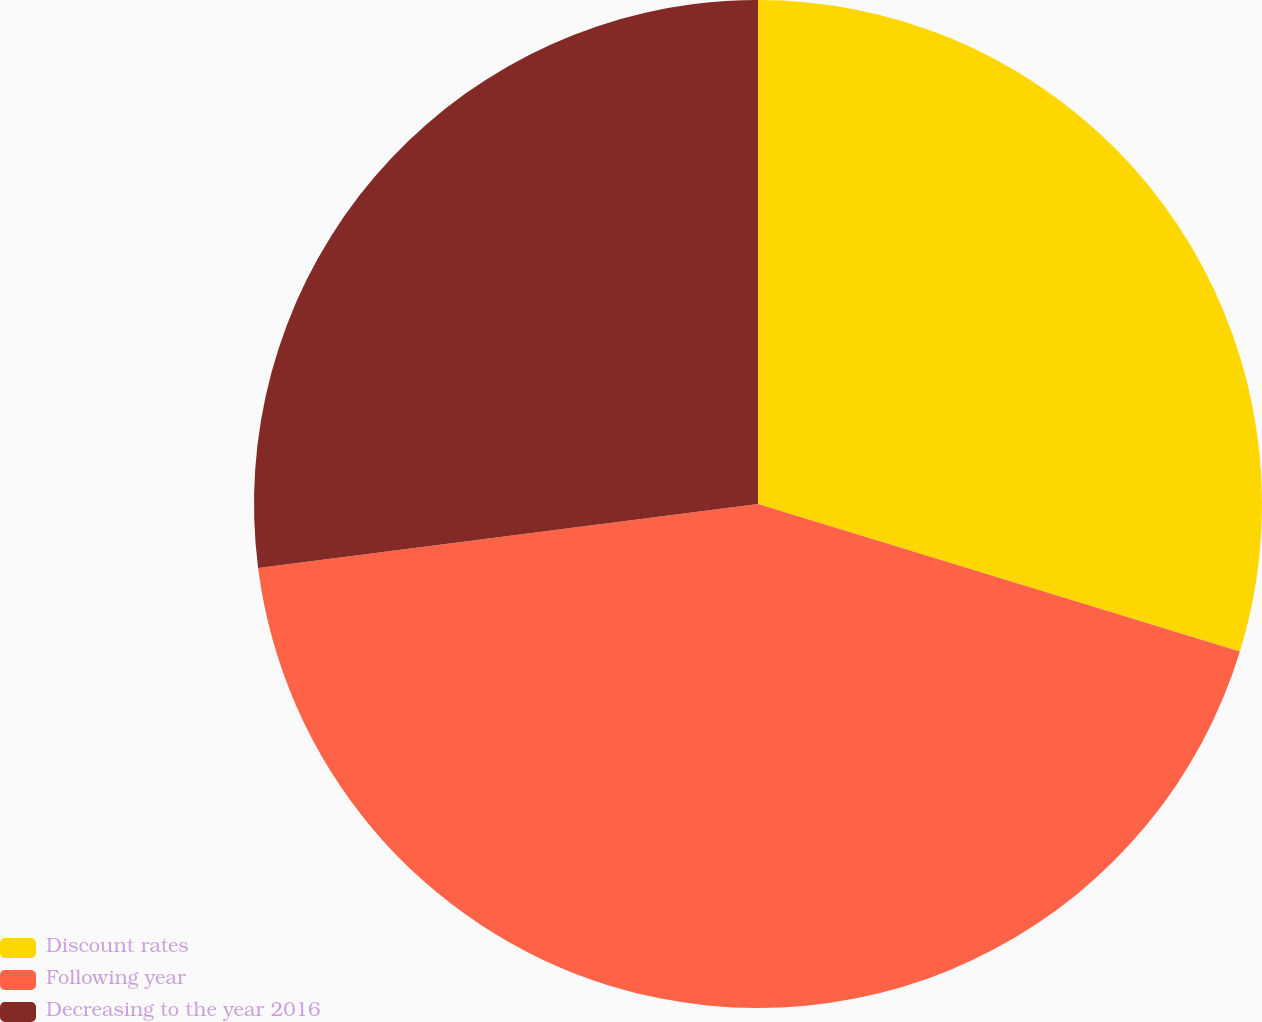Convert chart to OTSL. <chart><loc_0><loc_0><loc_500><loc_500><pie_chart><fcel>Discount rates<fcel>Following year<fcel>Decreasing to the year 2016<nl><fcel>29.73%<fcel>43.24%<fcel>27.03%<nl></chart> 